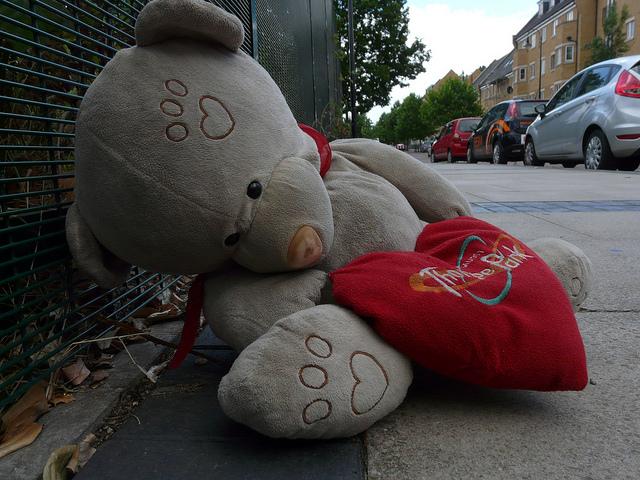What is the bear holding?
Quick response, please. Heart. What holiday season do you think it is?
Be succinct. Valentine's day. What does the heart say?
Quick response, please. Park. What is the animal standing on?
Keep it brief. Concrete. What color is the roof?
Keep it brief. Black. Is the stuffed bear in any danger?
Short answer required. No. What color is the bear?
Short answer required. Tan. Where is the toy?
Write a very short answer. Sidewalk. How many teddy bears are there?
Be succinct. 1. What word is readable in the photo?
Keep it brief. Park. 